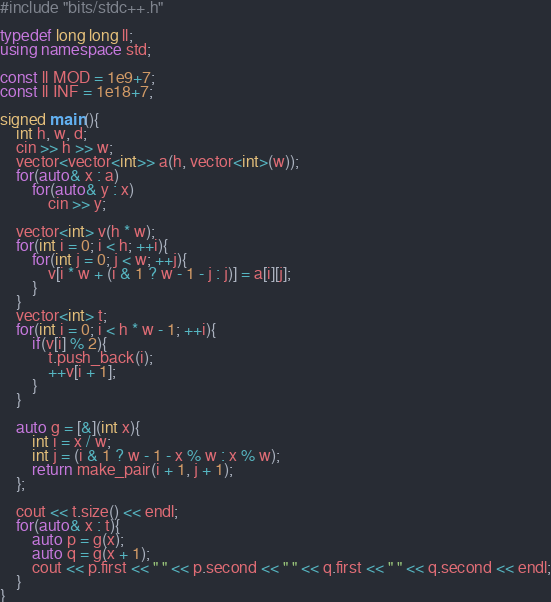<code> <loc_0><loc_0><loc_500><loc_500><_C++_>#include "bits/stdc++.h"

typedef long long ll;
using namespace std;

const ll MOD = 1e9+7;
const ll INF = 1e18+7;

signed main(){
	int h, w, d;
	cin >> h >> w;
	vector<vector<int>> a(h, vector<int>(w));
	for(auto& x : a)
		for(auto& y : x)
			cin >> y;

	vector<int> v(h * w);
	for(int i = 0; i < h; ++i){
		for(int j = 0; j < w; ++j){
			v[i * w + (i & 1 ? w - 1 - j : j)] = a[i][j];
		}
	}
	vector<int> t;
	for(int i = 0; i < h * w - 1; ++i){
		if(v[i] % 2){
			t.push_back(i);
			++v[i + 1];
		}
	}

	auto g = [&](int x){
		int i = x / w;
		int j = (i & 1 ? w - 1 - x % w : x % w);
		return make_pair(i + 1, j + 1);
	};

	cout << t.size() << endl;
	for(auto& x : t){
		auto p = g(x);
		auto q = g(x + 1);
		cout << p.first << " " << p.second << " " << q.first << " " << q.second << endl;
	}
}
</code> 